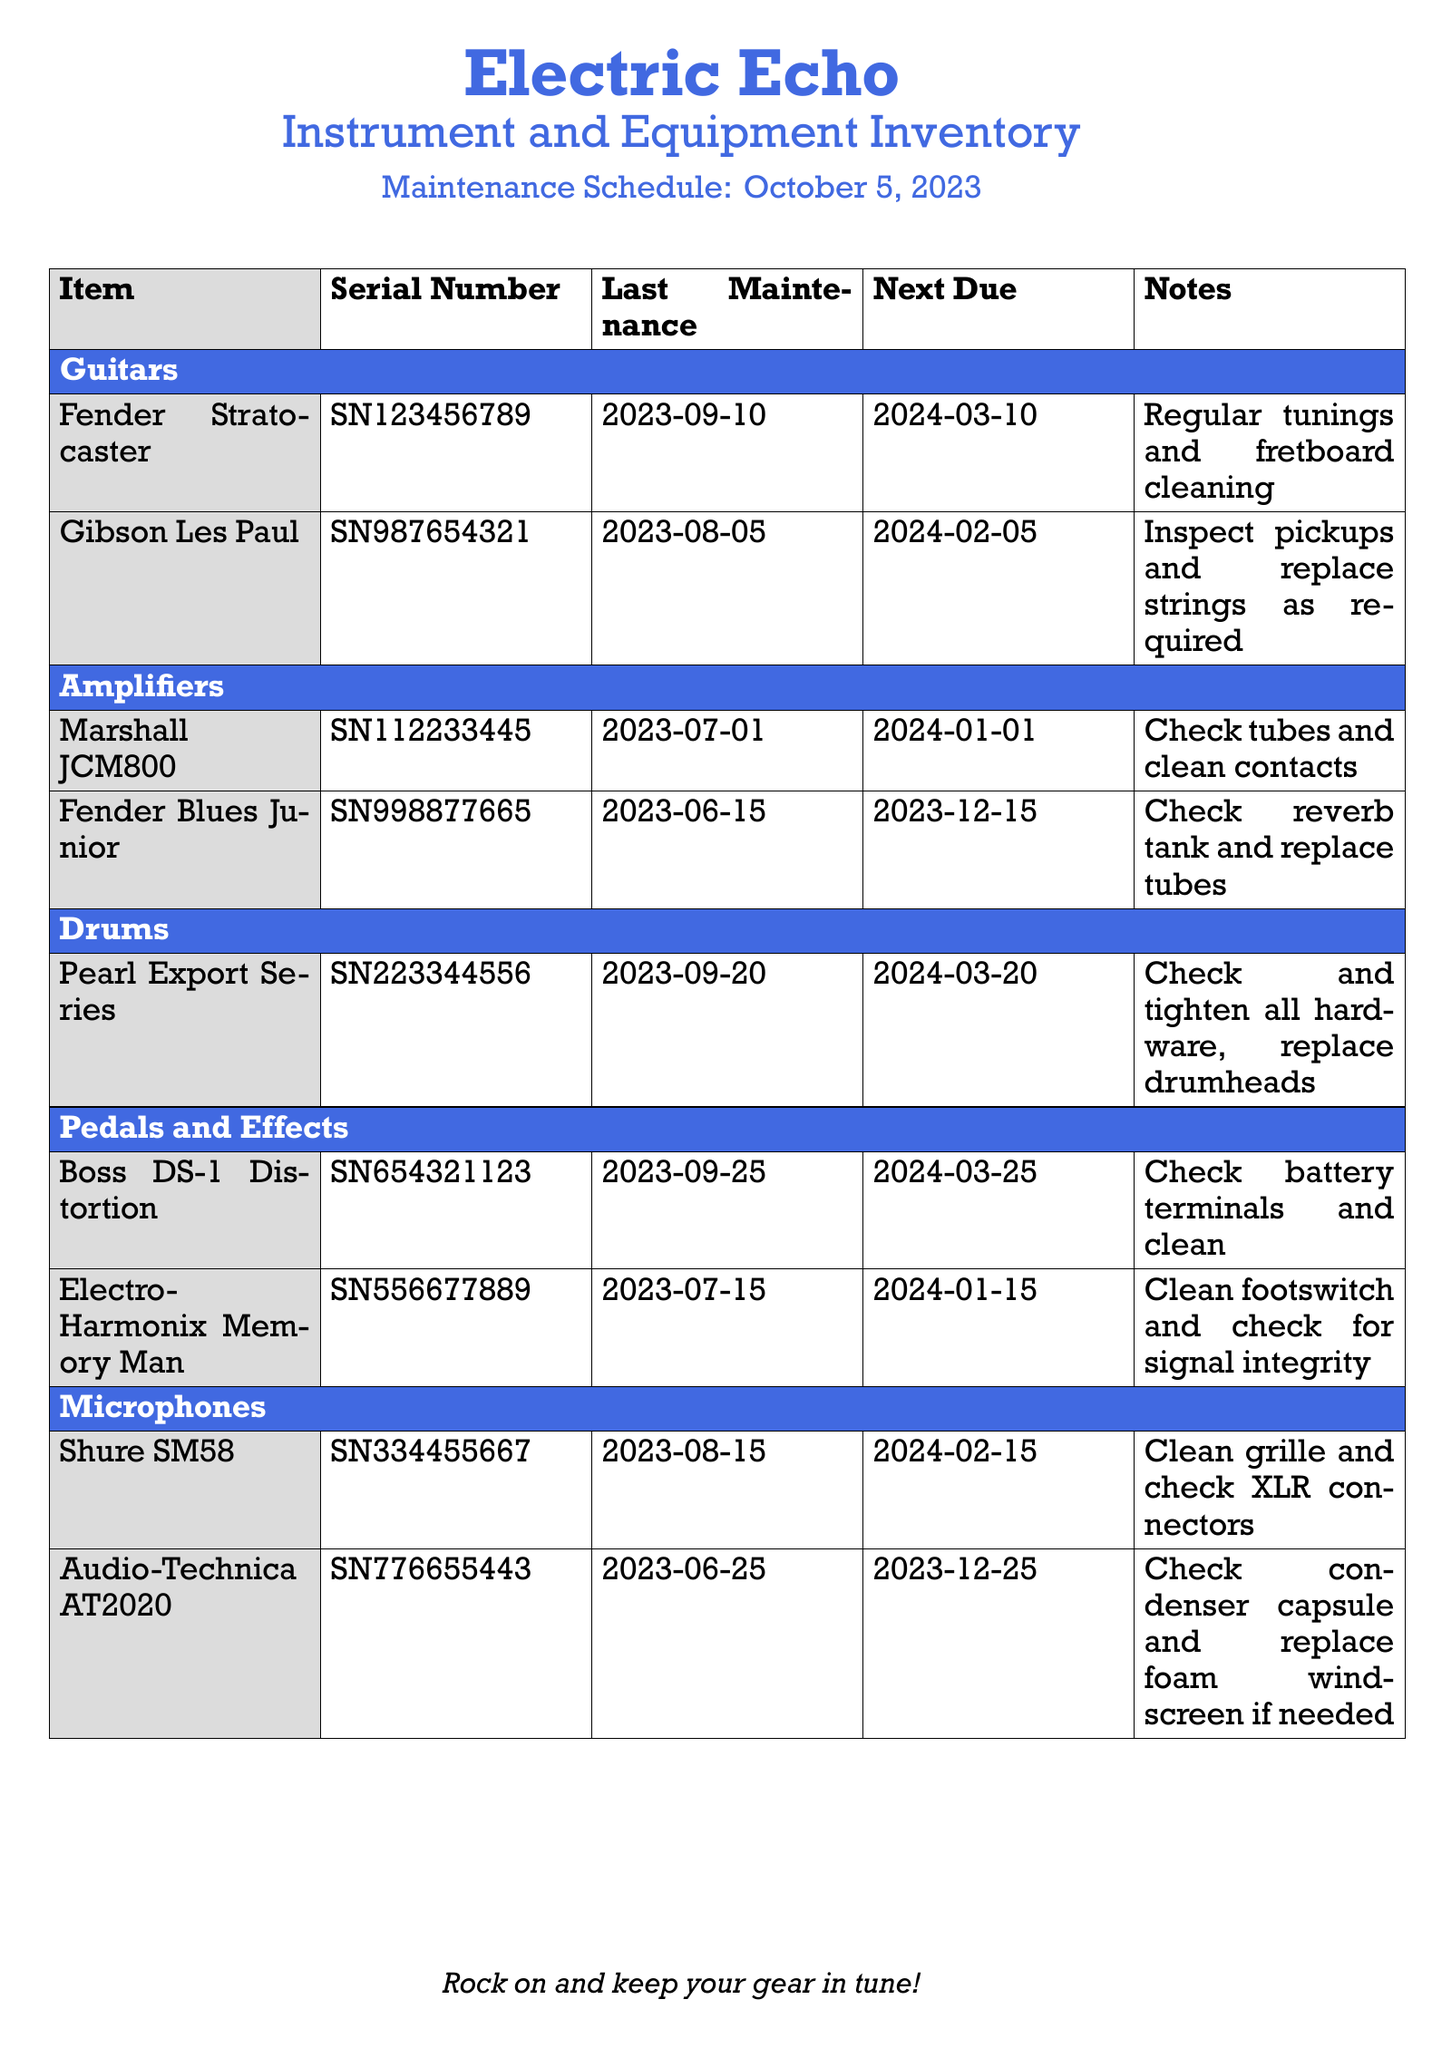what is the last maintenance date for Fender Stratocaster? The last maintenance date for the Fender Stratocaster is listed in the document under the "Last Maintenance" column for this item.
Answer: 2023-09-10 what is the next due maintenance for Gibson Les Paul? The next due maintenance date for the Gibson Les Paul can be found in the "Next Due" column for this item.
Answer: 2024-02-05 how many amplifiers are listed in the inventory? The document lists amplifiers as a category, and by counting the entries in that section, we can determine the total number.
Answer: 2 what type of drum set is mentioned in the inventory? The type of drum set is specified in the document, which is categorized under the "Drums" section.
Answer: Pearl Export Series which pedal needs maintenance the soonest? To find out which pedal requires maintenance soonest, we compare the "Next Due" dates for the pedals listed in the document.
Answer: Boss DS-1 Distortion when is the next maintenance for Electro-Harmonix Memory Man? The next maintenance for the Electro-Harmonix Memory Man can be found under the "Next Due" column for this item.
Answer: 2024-01-15 what maintenance is advised for the Shure SM58 microphone? The maintenance required for the Shure SM58 microphone is detailed in the "Notes" column of the document.
Answer: Clean grille and check XLR connectors which guitar requires fretboard cleaning? The requirement for fretboard cleaning is specified in the "Notes" section under the Guitars category in the document.
Answer: Fender Stratocaster 